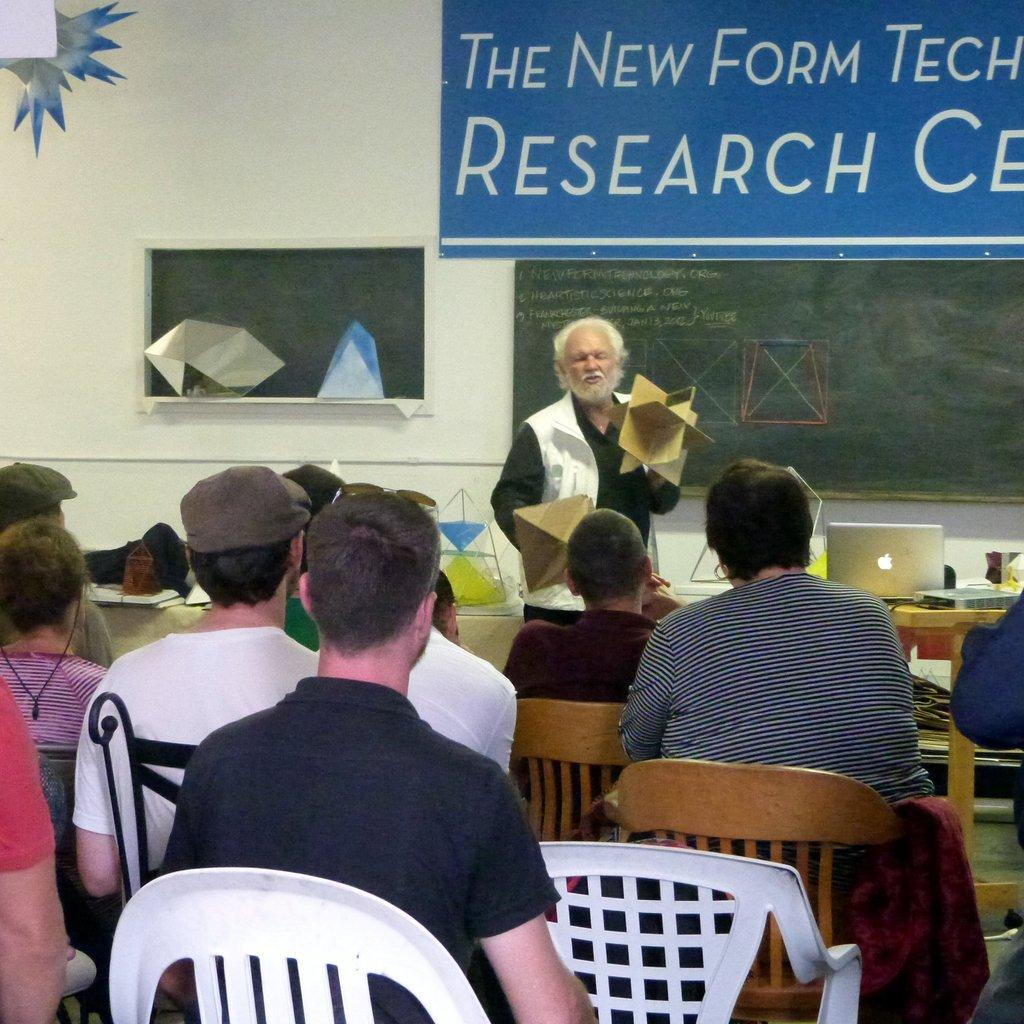What are the people in the image doing? The people in the image are sitting on chairs. Can you describe the background of the image? There is a man standing, a board, and a wall in the background of the image. What type of jellyfish can be seen swimming in the background of the image? There are no jellyfish present in the image; it features people sitting on chairs and a background with a man standing, a board, and a wall. 